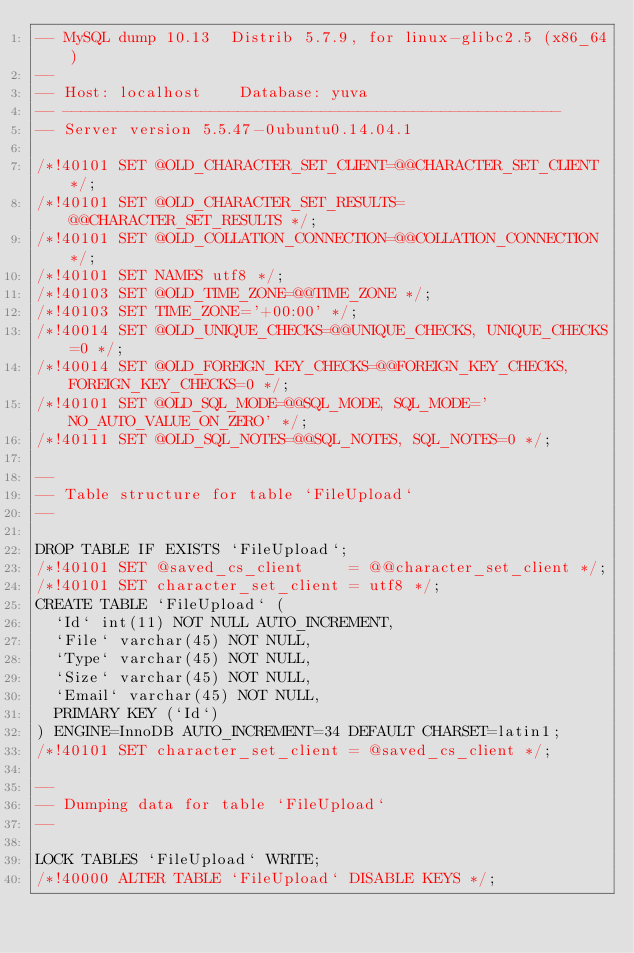Convert code to text. <code><loc_0><loc_0><loc_500><loc_500><_SQL_>-- MySQL dump 10.13  Distrib 5.7.9, for linux-glibc2.5 (x86_64)
--
-- Host: localhost    Database: yuva
-- ------------------------------------------------------
-- Server version	5.5.47-0ubuntu0.14.04.1

/*!40101 SET @OLD_CHARACTER_SET_CLIENT=@@CHARACTER_SET_CLIENT */;
/*!40101 SET @OLD_CHARACTER_SET_RESULTS=@@CHARACTER_SET_RESULTS */;
/*!40101 SET @OLD_COLLATION_CONNECTION=@@COLLATION_CONNECTION */;
/*!40101 SET NAMES utf8 */;
/*!40103 SET @OLD_TIME_ZONE=@@TIME_ZONE */;
/*!40103 SET TIME_ZONE='+00:00' */;
/*!40014 SET @OLD_UNIQUE_CHECKS=@@UNIQUE_CHECKS, UNIQUE_CHECKS=0 */;
/*!40014 SET @OLD_FOREIGN_KEY_CHECKS=@@FOREIGN_KEY_CHECKS, FOREIGN_KEY_CHECKS=0 */;
/*!40101 SET @OLD_SQL_MODE=@@SQL_MODE, SQL_MODE='NO_AUTO_VALUE_ON_ZERO' */;
/*!40111 SET @OLD_SQL_NOTES=@@SQL_NOTES, SQL_NOTES=0 */;

--
-- Table structure for table `FileUpload`
--

DROP TABLE IF EXISTS `FileUpload`;
/*!40101 SET @saved_cs_client     = @@character_set_client */;
/*!40101 SET character_set_client = utf8 */;
CREATE TABLE `FileUpload` (
  `Id` int(11) NOT NULL AUTO_INCREMENT,
  `File` varchar(45) NOT NULL,
  `Type` varchar(45) NOT NULL,
  `Size` varchar(45) NOT NULL,
  `Email` varchar(45) NOT NULL,
  PRIMARY KEY (`Id`)
) ENGINE=InnoDB AUTO_INCREMENT=34 DEFAULT CHARSET=latin1;
/*!40101 SET character_set_client = @saved_cs_client */;

--
-- Dumping data for table `FileUpload`
--

LOCK TABLES `FileUpload` WRITE;
/*!40000 ALTER TABLE `FileUpload` DISABLE KEYS */;</code> 